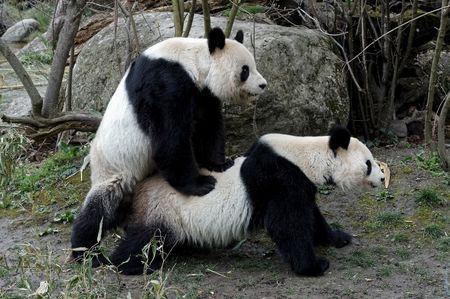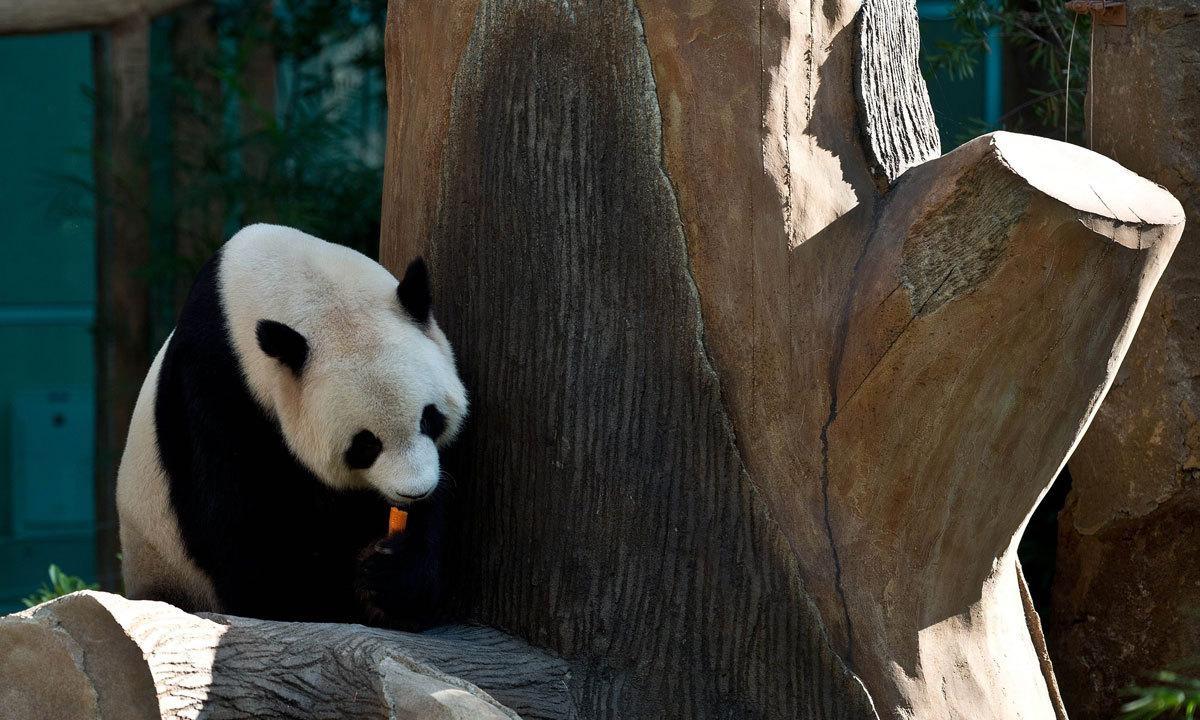The first image is the image on the left, the second image is the image on the right. Considering the images on both sides, is "One image shows a panda with its front paws on a large tree trunk, and the other image shows two pandas, one on top with its front paws on the other." valid? Answer yes or no. Yes. The first image is the image on the left, the second image is the image on the right. Considering the images on both sides, is "there are pandas mating next to a rock which is next to a tree trunk with windowed fencing and green posts in the back ground" valid? Answer yes or no. No. 